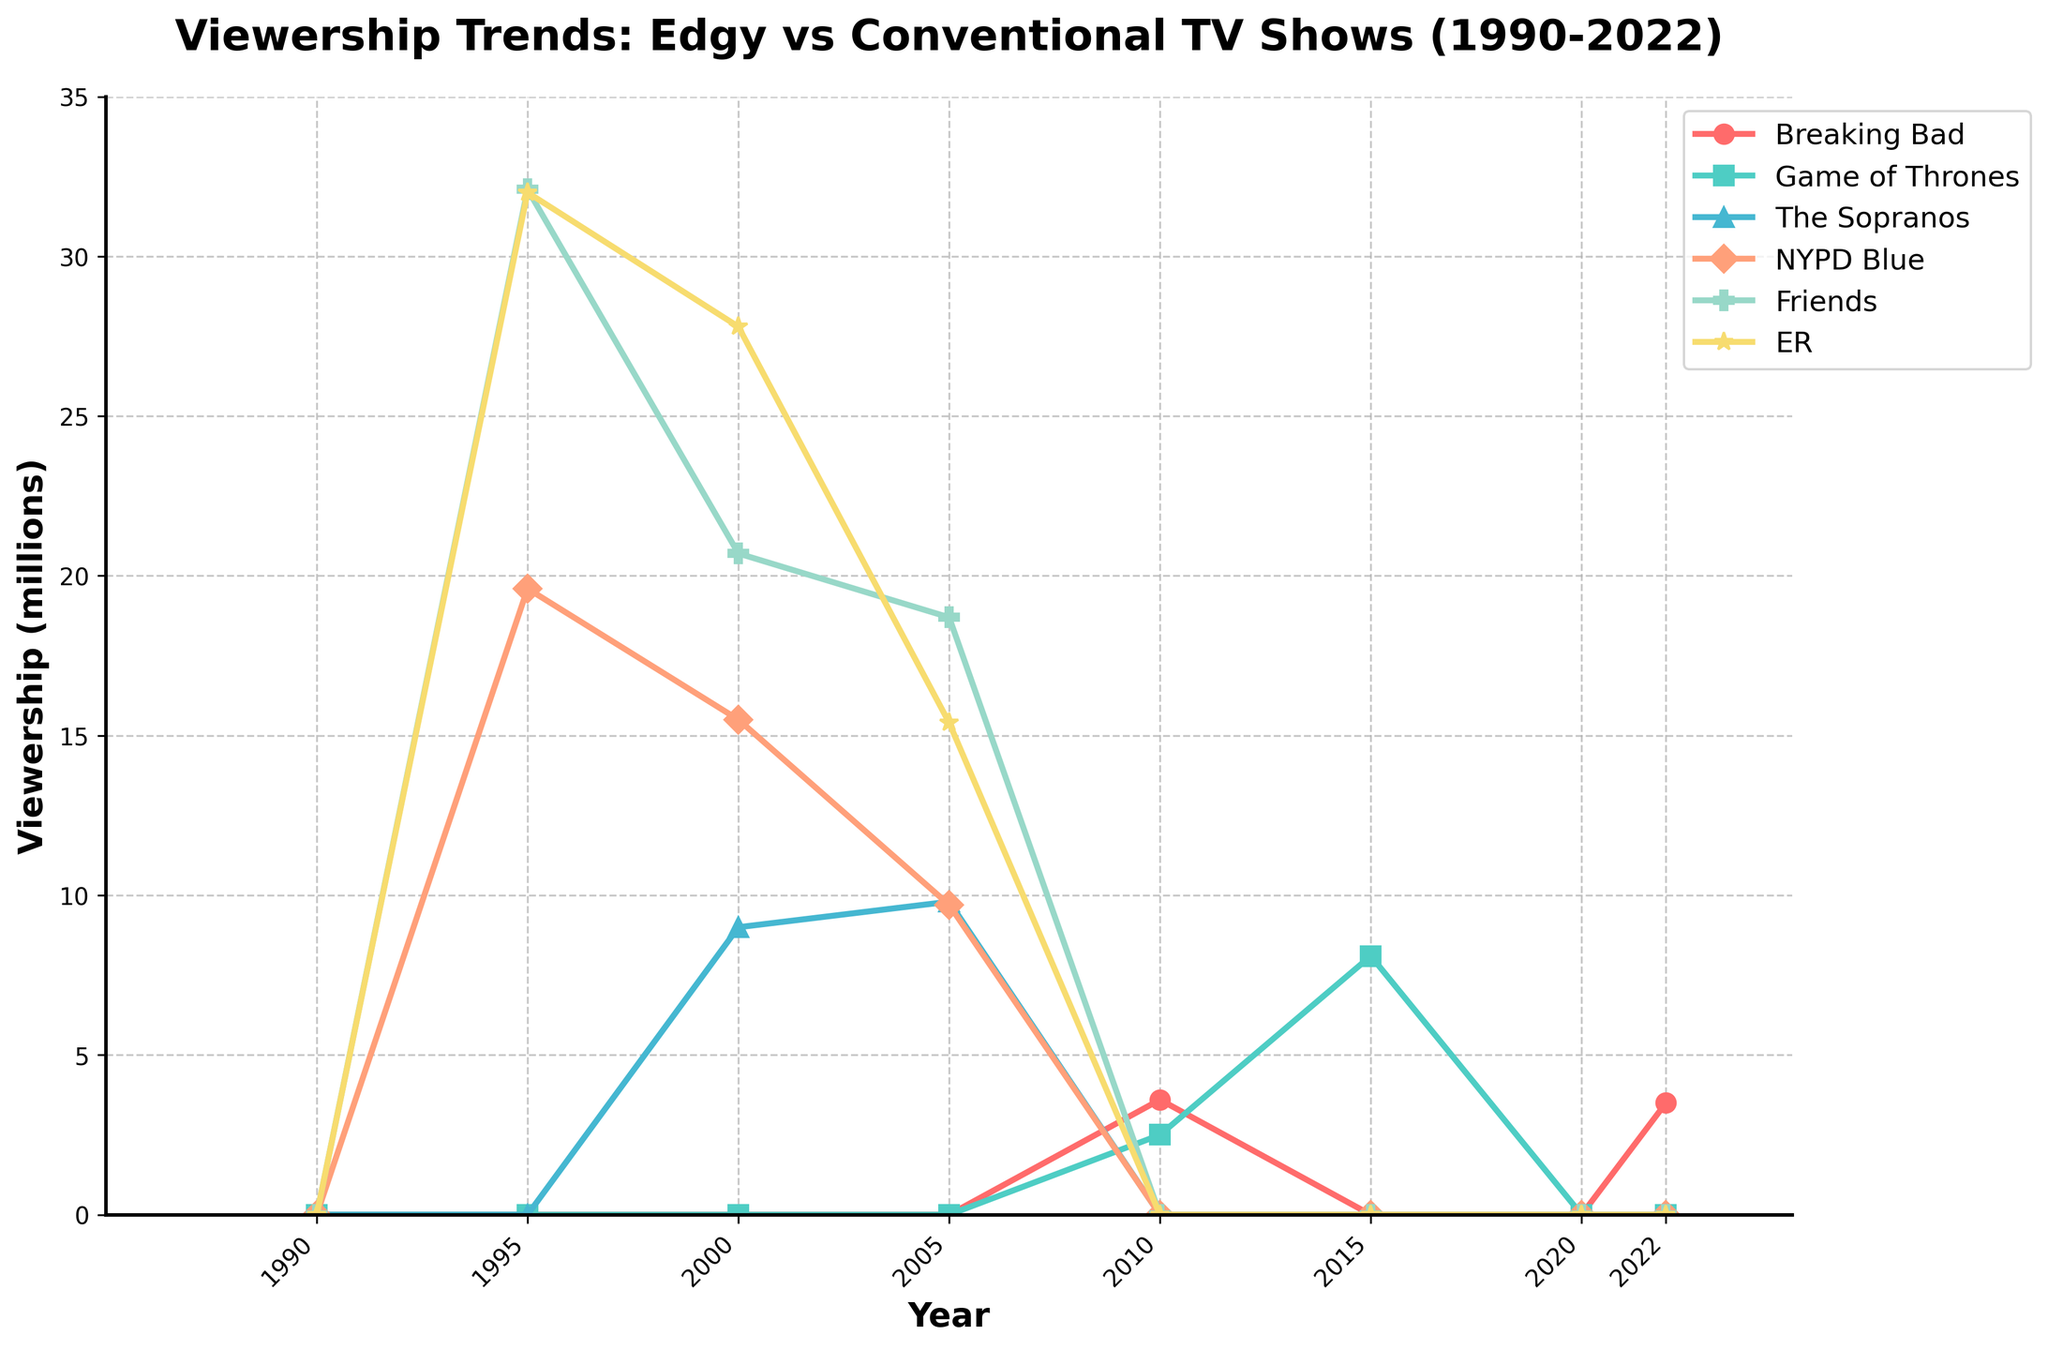Which two TV shows had the highest viewership in 1995? In 1995, 'Friends' had 32.1 million viewers and 'ER' had 32.0 million viewers, making them the highest.
Answer: Friends and ER What is the difference in viewership between 'Breaking Bad' in 2010 and 'Game of Thrones' in 2015? 'Breaking Bad' had 3.6 million viewers in 2010 and 'Game of Thrones' had 8.1 million viewers in 2015. The difference is 8.1 - 3.6 = 4.5 million viewers.
Answer: 4.5 million Which show had a declining trend in viewership from 2000 to 2005? By analyzing the curves from 2000 to 2005, 'NYPD Blue' shows a decline in viewership from 15.5 million to 9.7 million.
Answer: NYPD Blue During which year did 'Game of Thrones' peak in viewership? 'Game of Thrones' had the highest viewership in 2015 with 8.1 million viewers, and it was not listed after 2015.
Answer: 2015 How did 'The Sopranos' viewership change from 2000 to 2005? 'The Sopranos' had 9.0 million viewers in 2000 and slightly increased to 9.8 million viewers by 2005.
Answer: Slightly increased Was there ever a year where 'Breaking Bad' had more viewership than 'Friends'? 'Friends' had viewership data between 1995 and 2005, with a minimum viewership of 18.7 million in 2005, which is higher than 'Breaking Bad's peak viewership of 3.6 million in 2010.
Answer: No What is the average viewership of 'Friends' over its data points? 'Friends' viewership data points are 32.1, 20.7, and 18.7. The sum is 71.5. The average is 71.5/3 = 23.83 million viewers.
Answer: 23.83 million viewers Are there years recorded where both 'Breaking Bad' and 'Game of Thrones' had zero viewership? Both shows have zero viewership in years 1990, 1995, 2000, 2020.
Answer: Yes Compare the viewership trends of 'ER' and 'NYPD Blue' between 1995 and 2005. Who had the greater overall decline? 'ER' declined from 32.0 million to 15.4 million, a drop of 16.6 million. 'NYPD Blue' declined from 19.6 million to 9.7 million, a drop of 9.9 million. The decline of 'ER' is greater.
Answer: ER What year did 'The Sopranos' have no recorded viewership, despite data being available for another year before or after? In 2010, 'The Sopranos' had no recorded viewership even though data is available for 2005.
Answer: 2010 